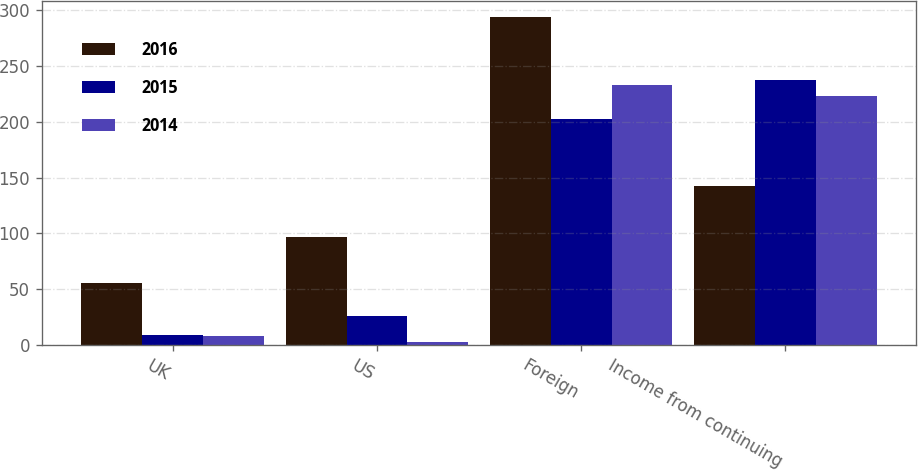Convert chart to OTSL. <chart><loc_0><loc_0><loc_500><loc_500><stacked_bar_chart><ecel><fcel>UK<fcel>US<fcel>Foreign<fcel>Income from continuing<nl><fcel>2016<fcel>55.4<fcel>96.4<fcel>294.1<fcel>142.3<nl><fcel>2015<fcel>8.9<fcel>26.1<fcel>202.8<fcel>237.8<nl><fcel>2014<fcel>7.6<fcel>2.3<fcel>233<fcel>223.1<nl></chart> 